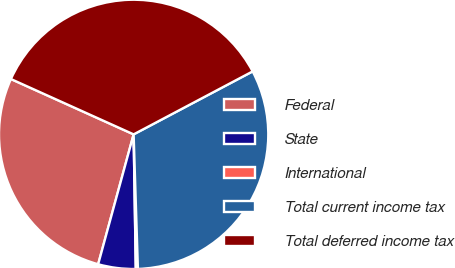Convert chart to OTSL. <chart><loc_0><loc_0><loc_500><loc_500><pie_chart><fcel>Federal<fcel>State<fcel>International<fcel>Total current income tax<fcel>Total deferred income tax<nl><fcel>27.5%<fcel>4.5%<fcel>0.25%<fcel>32.24%<fcel>35.51%<nl></chart> 